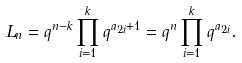Convert formula to latex. <formula><loc_0><loc_0><loc_500><loc_500>L _ { n } = q ^ { n - k } \prod _ { i = 1 } ^ { k } q ^ { a _ { 2 i } + 1 } = q ^ { n } \prod _ { i = 1 } ^ { k } q ^ { a _ { 2 i } } .</formula> 